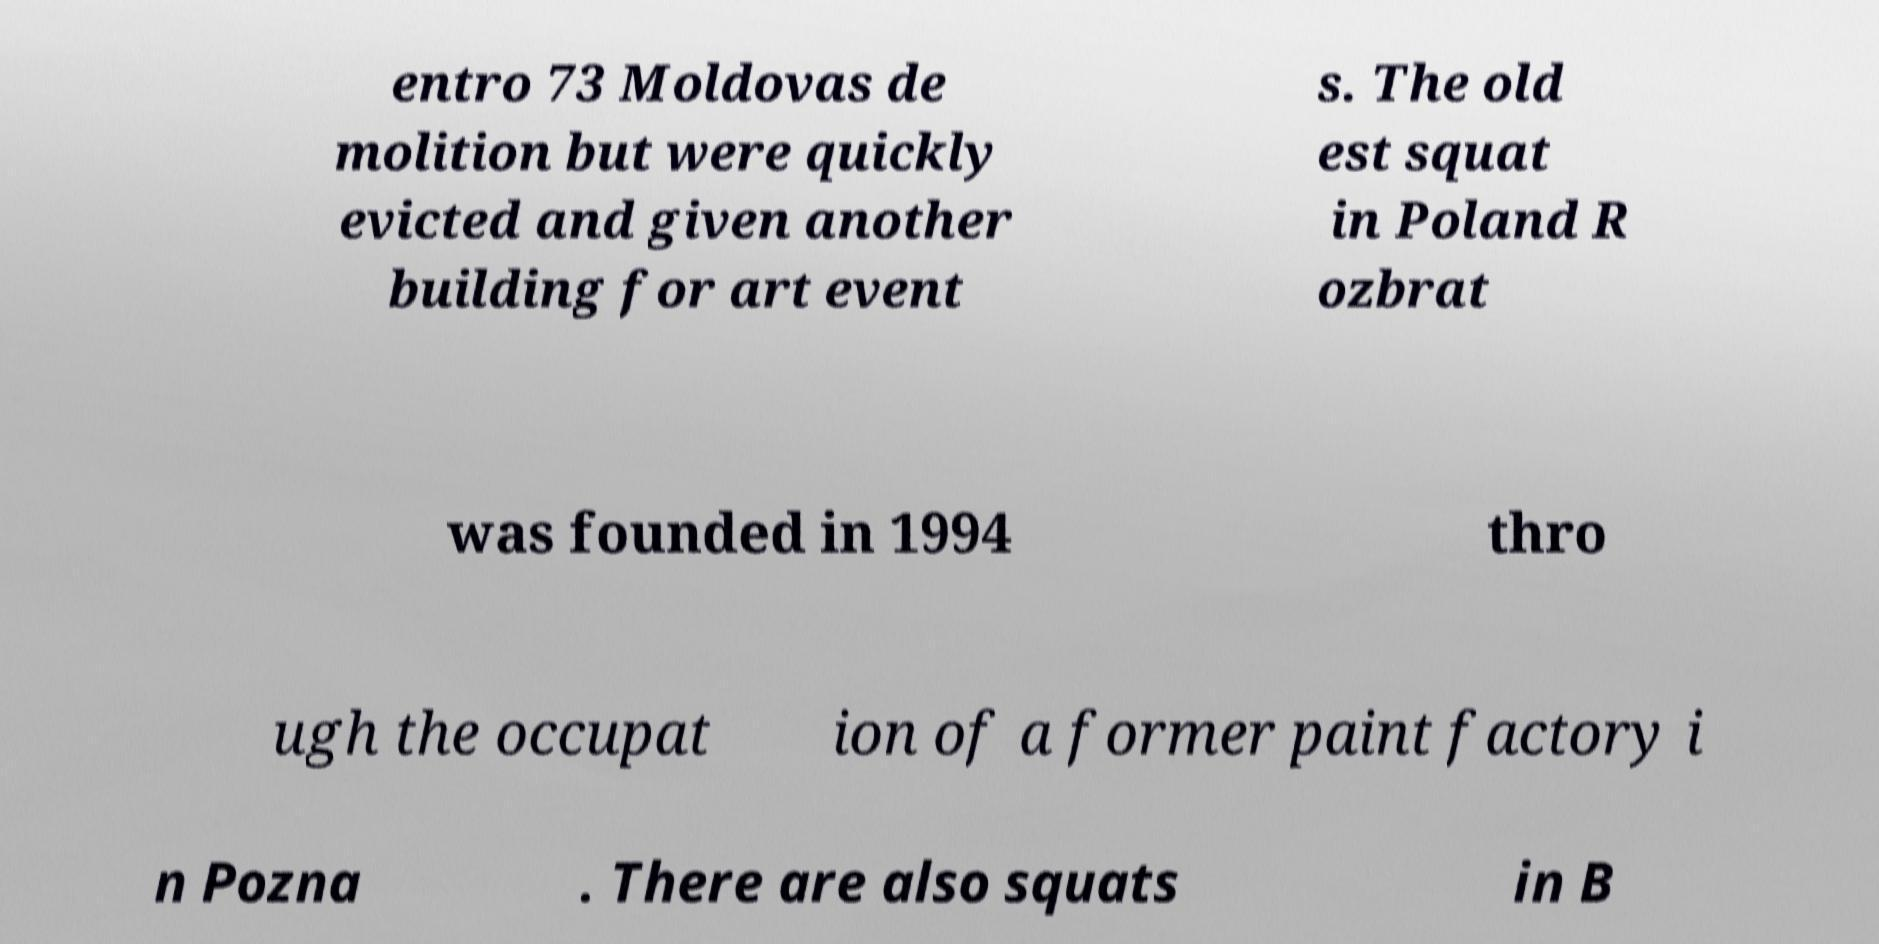Can you accurately transcribe the text from the provided image for me? entro 73 Moldovas de molition but were quickly evicted and given another building for art event s. The old est squat in Poland R ozbrat was founded in 1994 thro ugh the occupat ion of a former paint factory i n Pozna . There are also squats in B 